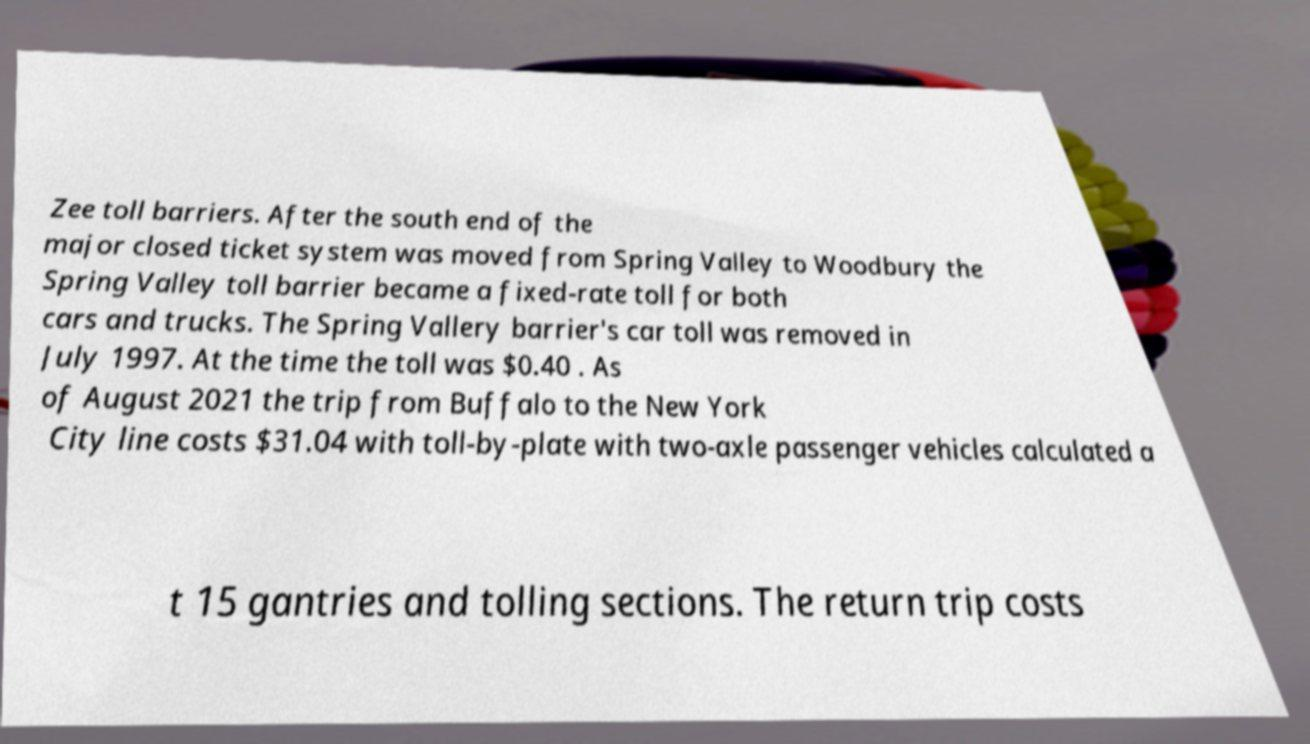Please read and relay the text visible in this image. What does it say? Zee toll barriers. After the south end of the major closed ticket system was moved from Spring Valley to Woodbury the Spring Valley toll barrier became a fixed-rate toll for both cars and trucks. The Spring Vallery barrier's car toll was removed in July 1997. At the time the toll was $0.40 . As of August 2021 the trip from Buffalo to the New York City line costs $31.04 with toll-by-plate with two-axle passenger vehicles calculated a t 15 gantries and tolling sections. The return trip costs 